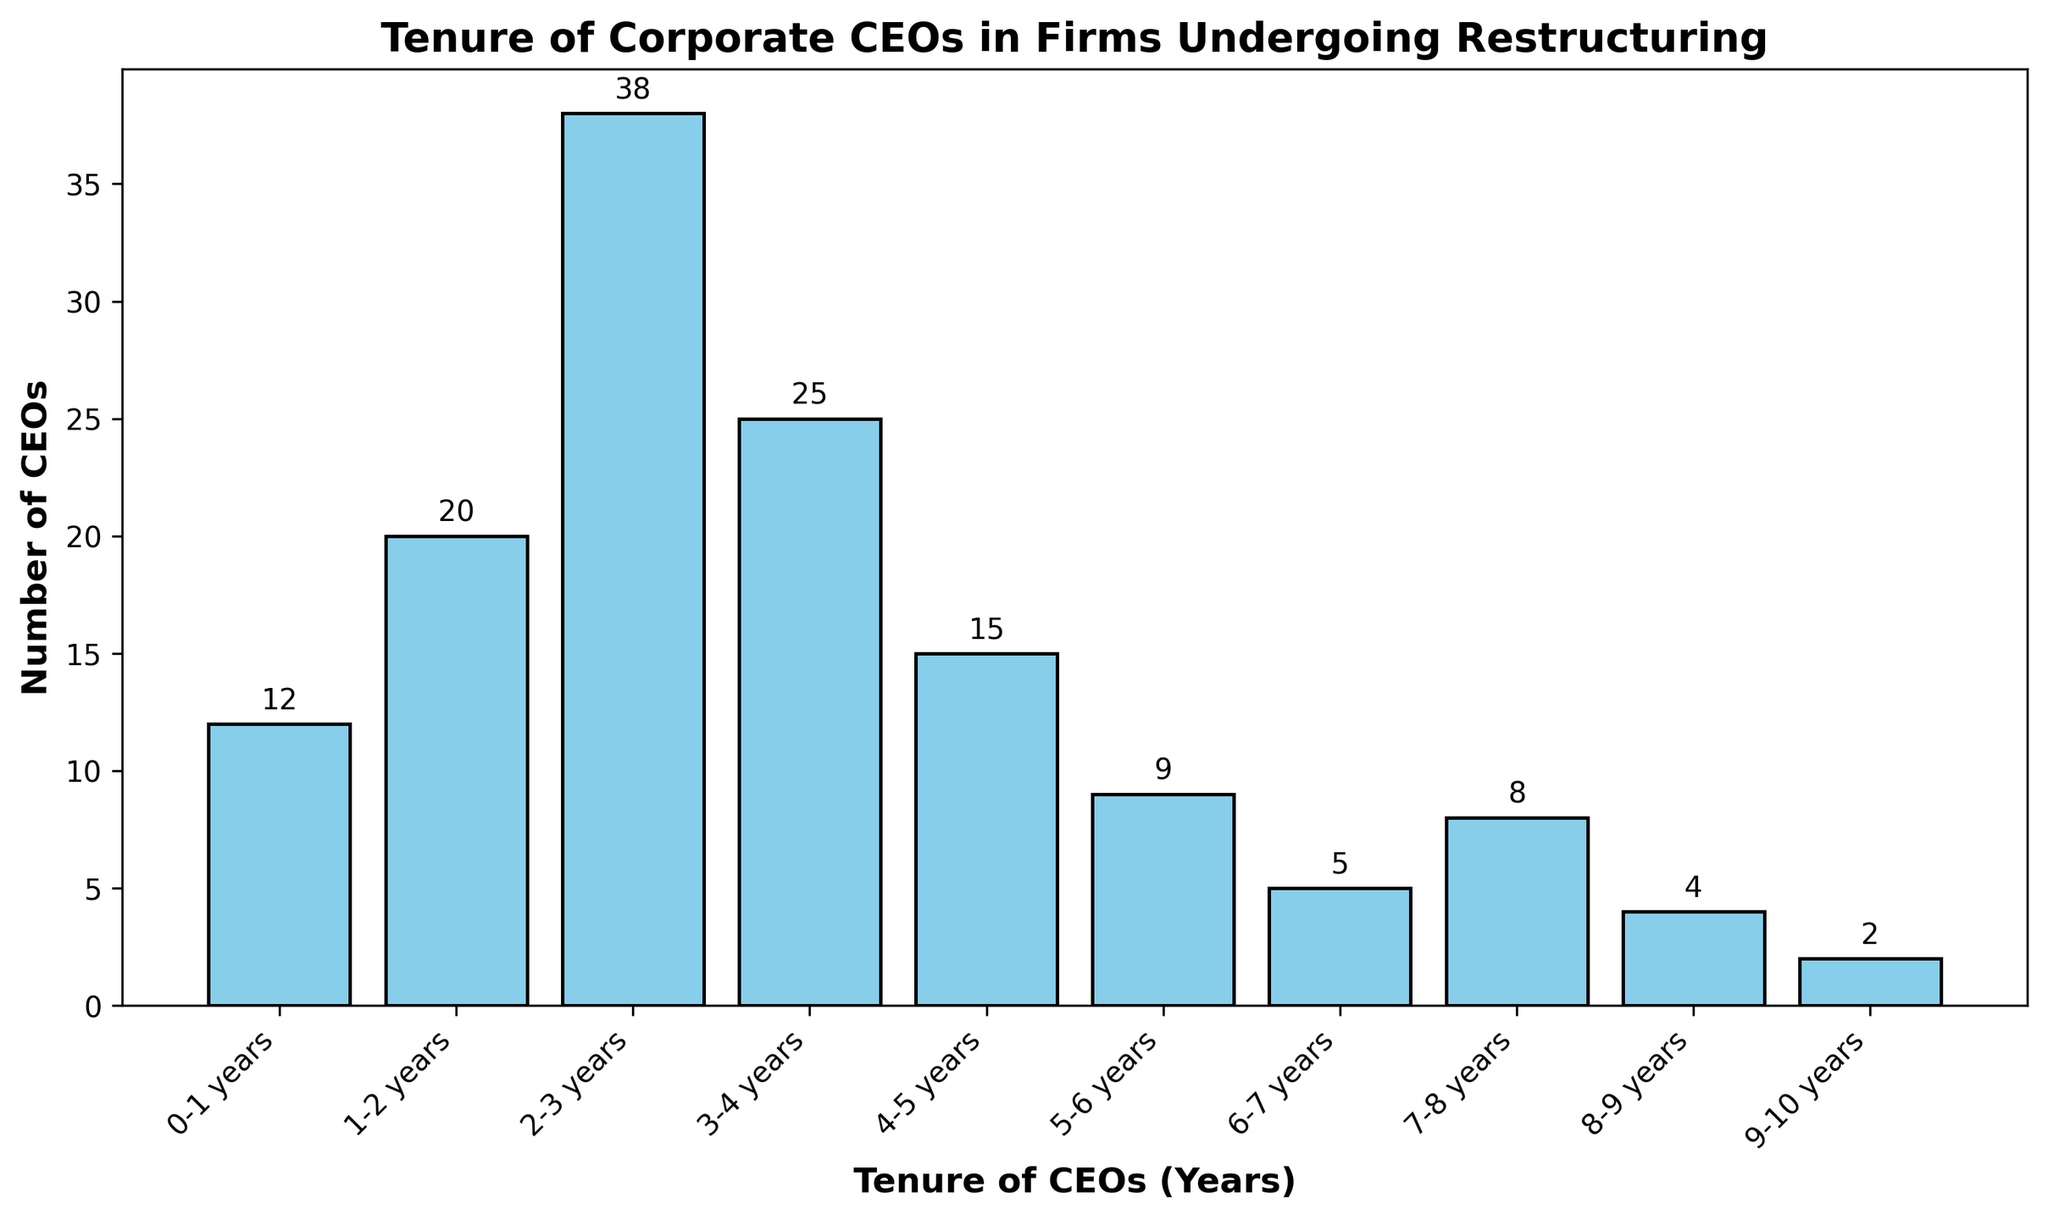Which tenure range has the highest number of CEOs? By looking at the heights of the bars, we need to identify the tallest bar. The bar representing the "2-3 years" tenure range is the tallest.
Answer: 2-3 years Which tenure range has the lowest number of CEOs? Observe the bar heights and find the shortest one. The bar for "9-10 years" is the shortest, indicating the least number of CEOs.
Answer: 9-10 years How many CEOs have tenures of 3 years or less? Add the counts for tenure ranges "0-1 years", "1-2 years", "2-3 years". The counts are 12, 20, and 38, respectively. 12 + 20 + 38 = 70.
Answer: 70 What is the combined number of CEOs with tenures longer than 6 years? Add the counts for tenure ranges "6-7 years", "7-8 years", "8-9 years", and "9-10 years". The counts are 5, 8, 4, and 2, respectively. 5 + 8 + 4 + 2 = 19.
Answer: 19 How does the number of CEOs with 4-5 years of tenure compare to those with 5-6 years of tenure? Compare the bar heights for "4-5 years" (15) and "5-6 years" (9). The "4-5 years" bar is higher.
Answer: More CEOs in 4-5 years What is the total number of CEOs represented in the histogram? Sum the counts for all the tenure ranges: 12 + 20 + 38 + 25 + 15 + 9 + 5 + 8 + 4 + 2 = 138.
Answer: 138 Which tenure range(s) have fewer than 10 CEOs? Identify bars with heights less than 10. The tenure ranges are "5-6 years", "6-7 years", "8-9 years", and "9-10 years", which have counts 9, 5, 4, and 2, respectively.
Answer: 5-6, 6-7, 8-9, 9-10 years How many more CEOs have a tenure of 2-3 years than 4-5 years? Subtract the count of "4-5 years" (15) from "2-3 years" (38). 38 - 15 = 23.
Answer: 23 What is the percentage of CEOs with tenures between 1-2 years out of the total CEOs? Calculate the percentage: (20 / 138) x 100 ≈ 14.49%.
Answer: ~14.49% Which tenure ranges have counts that are even numbers? Identify the bars with even number counts: "0-1 years" (12), "1-2 years" (20), "2-3 years" (38), "4-5 years" (15 is not even), "6-7 years" (5 is not even), "7-8 years" (8), "8-9 years" (4), "9-10 years" (2).
Answer: 0-1, 1-2, 2-3, 7-8, 8-9, 9-10 years 